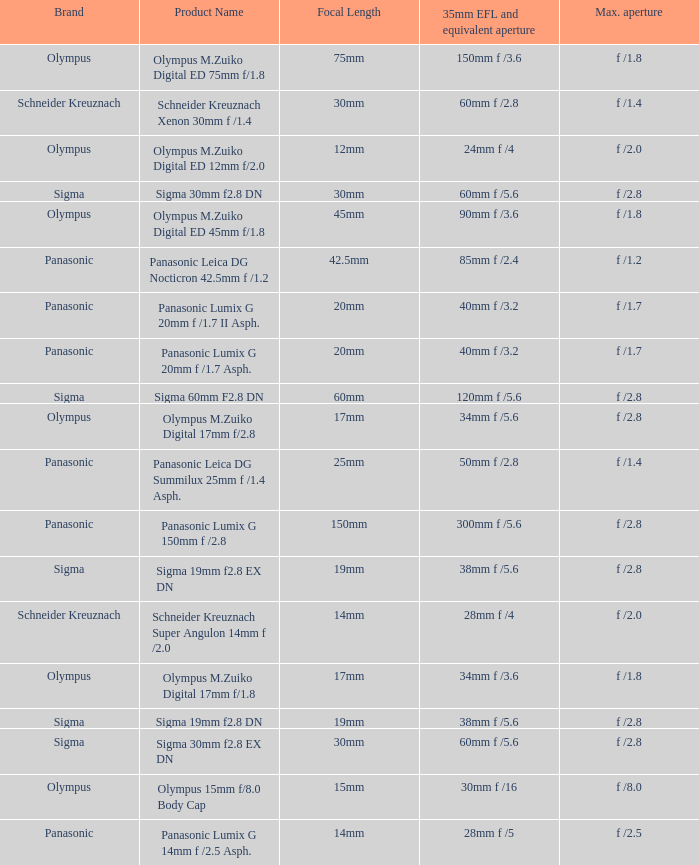What is the 35mm EFL and the equivalent aperture of the lens(es) with a maximum aperture of f /2.5? 28mm f /5. 